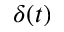Convert formula to latex. <formula><loc_0><loc_0><loc_500><loc_500>\delta ( t )</formula> 